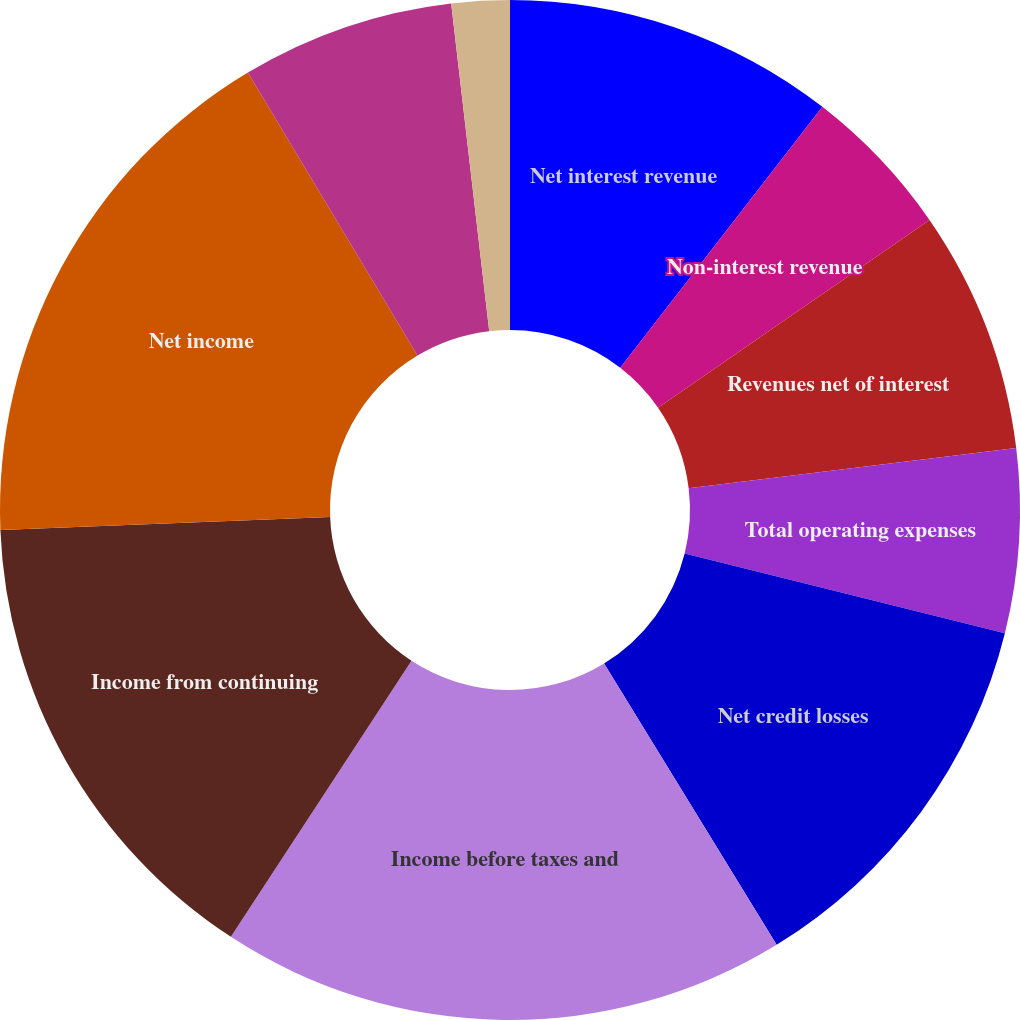Convert chart to OTSL. <chart><loc_0><loc_0><loc_500><loc_500><pie_chart><fcel>Net interest revenue<fcel>Non-interest revenue<fcel>Revenues net of interest<fcel>Total operating expenses<fcel>Net credit losses<fcel>Income before taxes and<fcel>Income from continuing<fcel>Net income<fcel>Average assets (in billions of<fcel>North America<nl><fcel>10.49%<fcel>4.88%<fcel>7.69%<fcel>5.82%<fcel>12.36%<fcel>17.97%<fcel>15.16%<fcel>17.03%<fcel>6.75%<fcel>1.84%<nl></chart> 